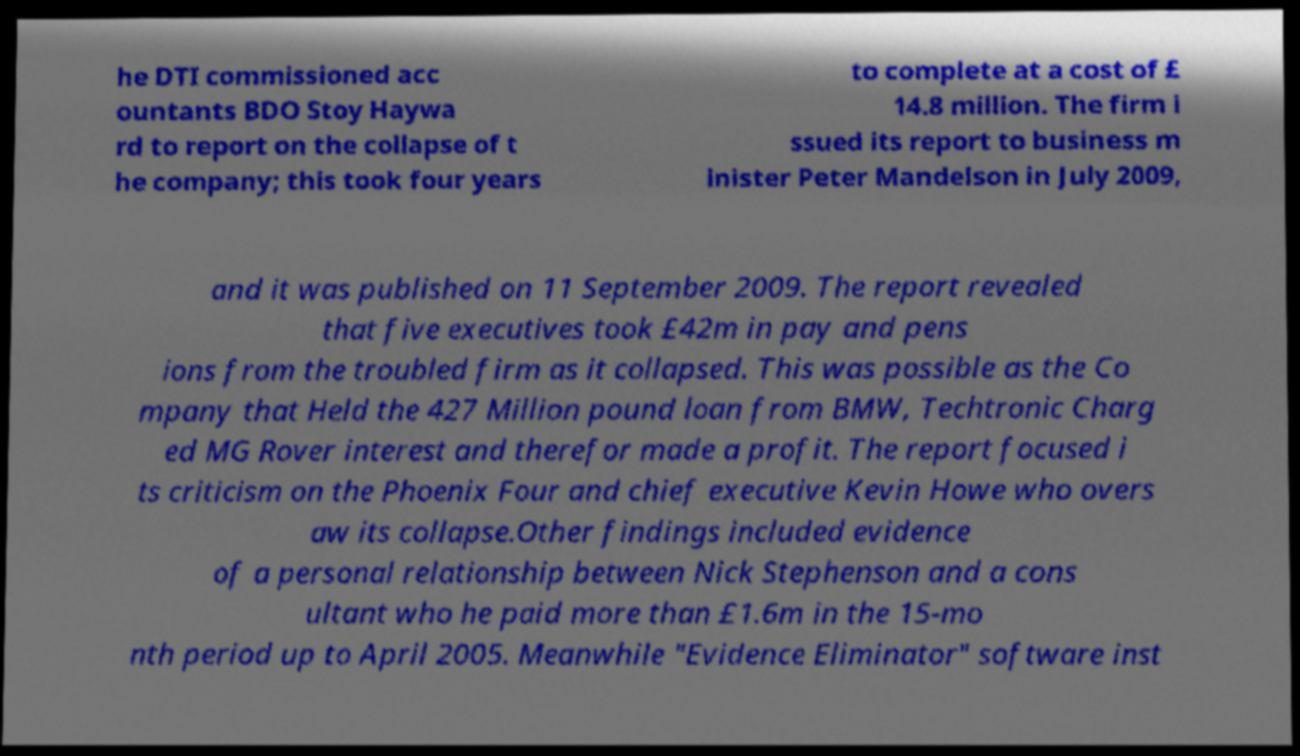Can you read and provide the text displayed in the image?This photo seems to have some interesting text. Can you extract and type it out for me? he DTI commissioned acc ountants BDO Stoy Haywa rd to report on the collapse of t he company; this took four years to complete at a cost of £ 14.8 million. The firm i ssued its report to business m inister Peter Mandelson in July 2009, and it was published on 11 September 2009. The report revealed that five executives took £42m in pay and pens ions from the troubled firm as it collapsed. This was possible as the Co mpany that Held the 427 Million pound loan from BMW, Techtronic Charg ed MG Rover interest and therefor made a profit. The report focused i ts criticism on the Phoenix Four and chief executive Kevin Howe who overs aw its collapse.Other findings included evidence of a personal relationship between Nick Stephenson and a cons ultant who he paid more than £1.6m in the 15-mo nth period up to April 2005. Meanwhile "Evidence Eliminator" software inst 